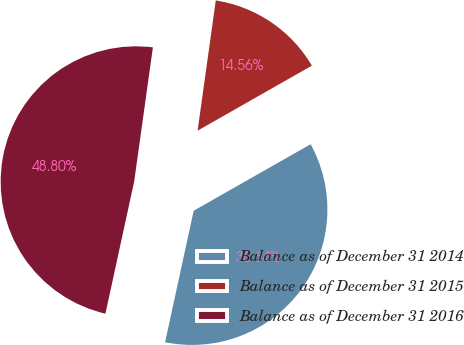Convert chart to OTSL. <chart><loc_0><loc_0><loc_500><loc_500><pie_chart><fcel>Balance as of December 31 2014<fcel>Balance as of December 31 2015<fcel>Balance as of December 31 2016<nl><fcel>36.64%<fcel>14.56%<fcel>48.8%<nl></chart> 